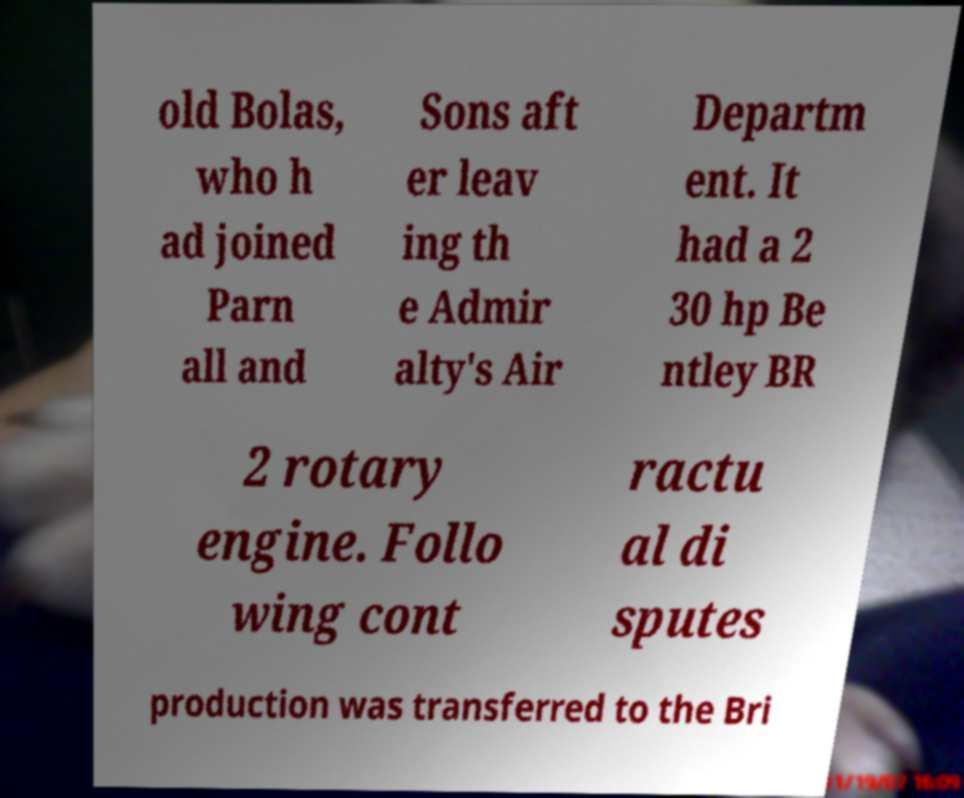Please read and relay the text visible in this image. What does it say? old Bolas, who h ad joined Parn all and Sons aft er leav ing th e Admir alty's Air Departm ent. It had a 2 30 hp Be ntley BR 2 rotary engine. Follo wing cont ractu al di sputes production was transferred to the Bri 